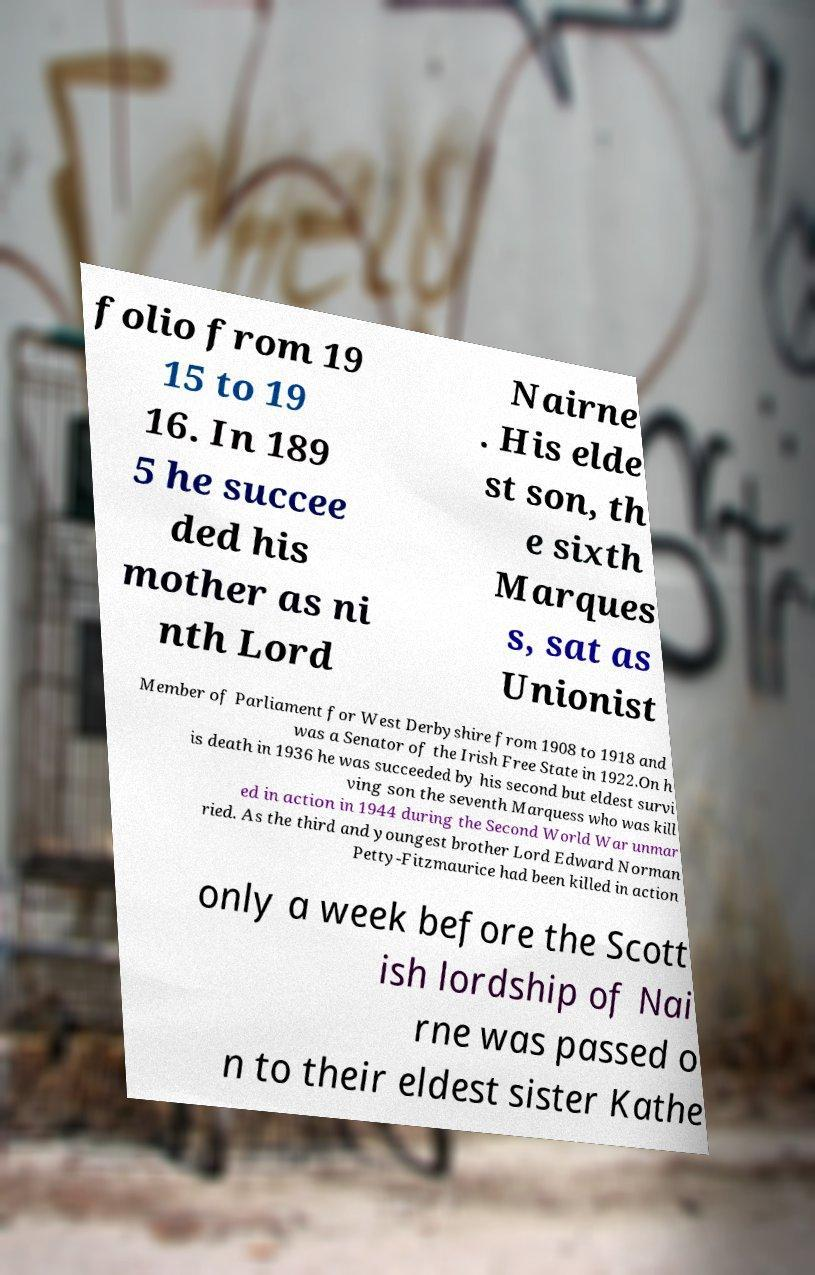Please identify and transcribe the text found in this image. folio from 19 15 to 19 16. In 189 5 he succee ded his mother as ni nth Lord Nairne . His elde st son, th e sixth Marques s, sat as Unionist Member of Parliament for West Derbyshire from 1908 to 1918 and was a Senator of the Irish Free State in 1922.On h is death in 1936 he was succeeded by his second but eldest survi ving son the seventh Marquess who was kill ed in action in 1944 during the Second World War unmar ried. As the third and youngest brother Lord Edward Norman Petty-Fitzmaurice had been killed in action only a week before the Scott ish lordship of Nai rne was passed o n to their eldest sister Kathe 